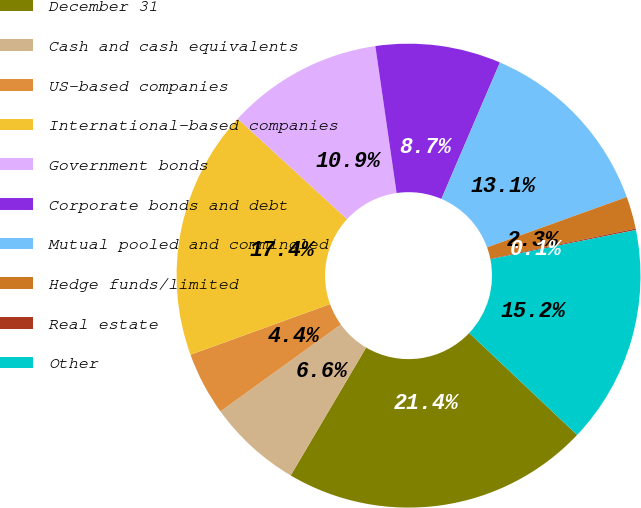Convert chart. <chart><loc_0><loc_0><loc_500><loc_500><pie_chart><fcel>December 31<fcel>Cash and cash equivalents<fcel>US-based companies<fcel>International-based companies<fcel>Government bonds<fcel>Corporate bonds and debt<fcel>Mutual pooled and commingled<fcel>Hedge funds/limited<fcel>Real estate<fcel>Other<nl><fcel>21.43%<fcel>6.57%<fcel>4.41%<fcel>17.36%<fcel>10.89%<fcel>8.73%<fcel>13.05%<fcel>2.25%<fcel>0.1%<fcel>15.2%<nl></chart> 